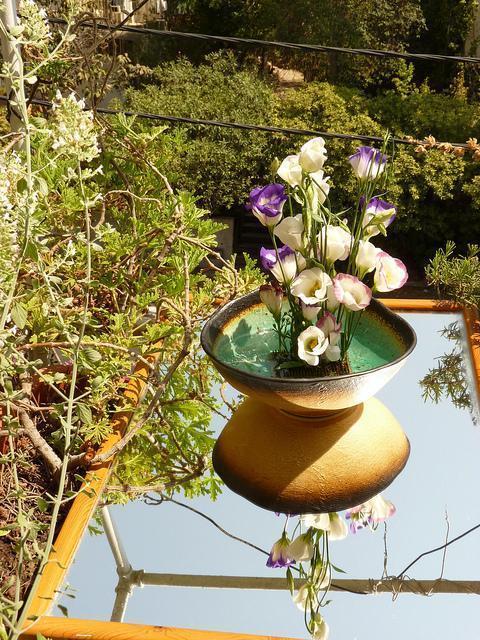How many vases are visible?
Give a very brief answer. 2. How many birds on the beach are the right side of the surfers?
Give a very brief answer. 0. 